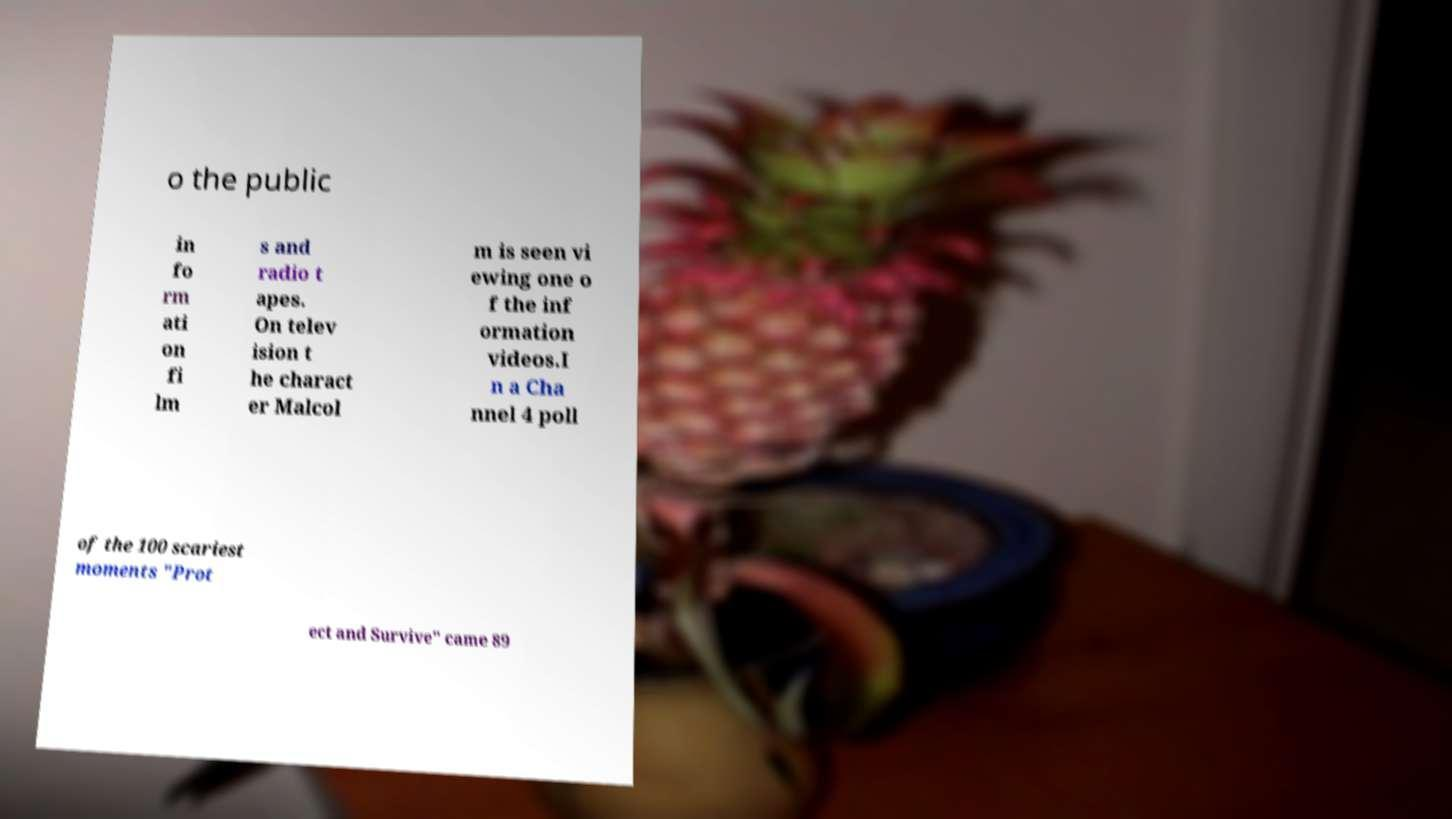Could you assist in decoding the text presented in this image and type it out clearly? o the public in fo rm ati on fi lm s and radio t apes. On telev ision t he charact er Malcol m is seen vi ewing one o f the inf ormation videos.I n a Cha nnel 4 poll of the 100 scariest moments "Prot ect and Survive" came 89 